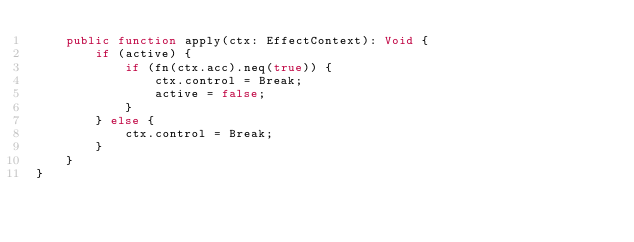Convert code to text. <code><loc_0><loc_0><loc_500><loc_500><_Haxe_>    public function apply(ctx: EffectContext): Void {
        if (active) {
            if (fn(ctx.acc).neq(true)) {
                ctx.control = Break;
                active = false;
            }
        } else {
            ctx.control = Break;
        }
    }
}</code> 